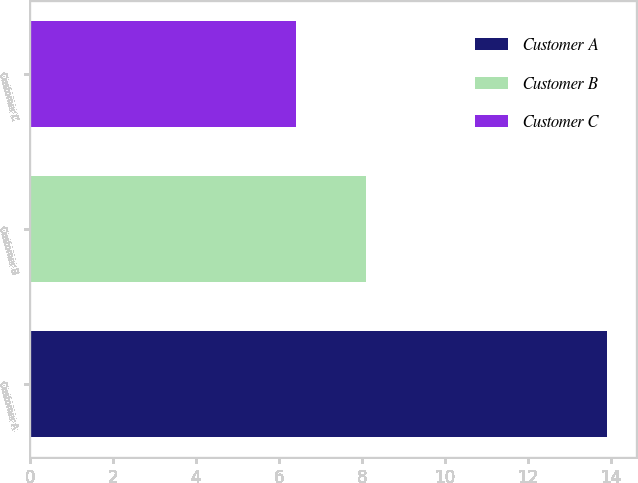Convert chart. <chart><loc_0><loc_0><loc_500><loc_500><bar_chart><fcel>Customer A<fcel>Customer B<fcel>Customer C<nl><fcel>13.9<fcel>8.1<fcel>6.4<nl></chart> 